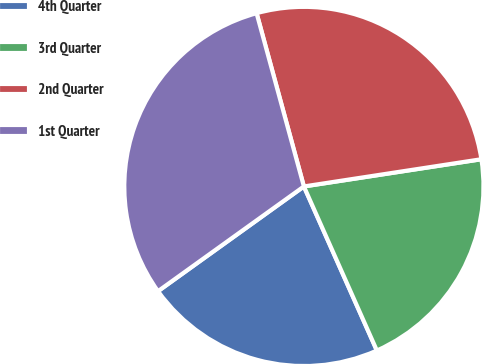Convert chart to OTSL. <chart><loc_0><loc_0><loc_500><loc_500><pie_chart><fcel>4th Quarter<fcel>3rd Quarter<fcel>2nd Quarter<fcel>1st Quarter<nl><fcel>21.75%<fcel>20.76%<fcel>26.82%<fcel>30.67%<nl></chart> 